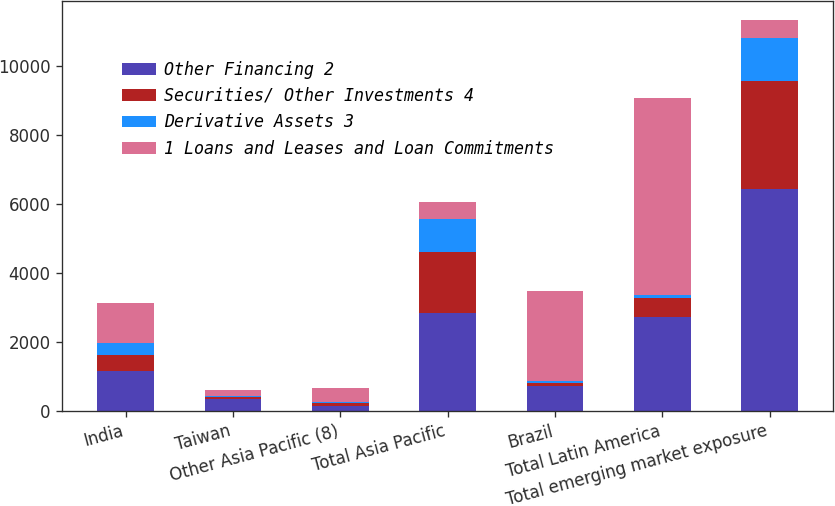Convert chart to OTSL. <chart><loc_0><loc_0><loc_500><loc_500><stacked_bar_chart><ecel><fcel>India<fcel>Taiwan<fcel>Other Asia Pacific (8)<fcel>Total Asia Pacific<fcel>Brazil<fcel>Total Latin America<fcel>Total emerging market exposure<nl><fcel>Other Financing 2<fcel>1141<fcel>345<fcel>133<fcel>2835<fcel>701<fcel>2712<fcel>6427<nl><fcel>Securities/ Other Investments 4<fcel>470<fcel>41<fcel>79<fcel>1785<fcel>104<fcel>558<fcel>3140<nl><fcel>Derivative Assets 3<fcel>355<fcel>45<fcel>35<fcel>936<fcel>42<fcel>80<fcel>1261<nl><fcel>1 Loans and Leases and Loan Commitments<fcel>1168<fcel>169<fcel>401<fcel>514<fcel>2617<fcel>5731<fcel>514<nl></chart> 